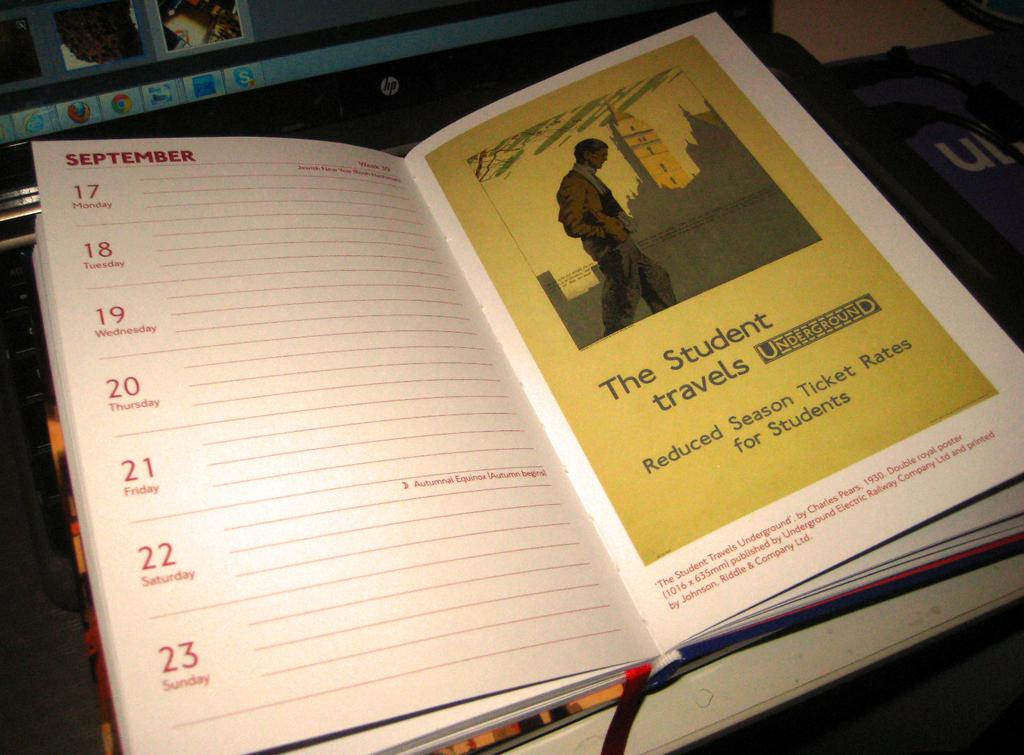<image>
Relay a brief, clear account of the picture shown. The Student travel underground lays open to the week of September 17th. 